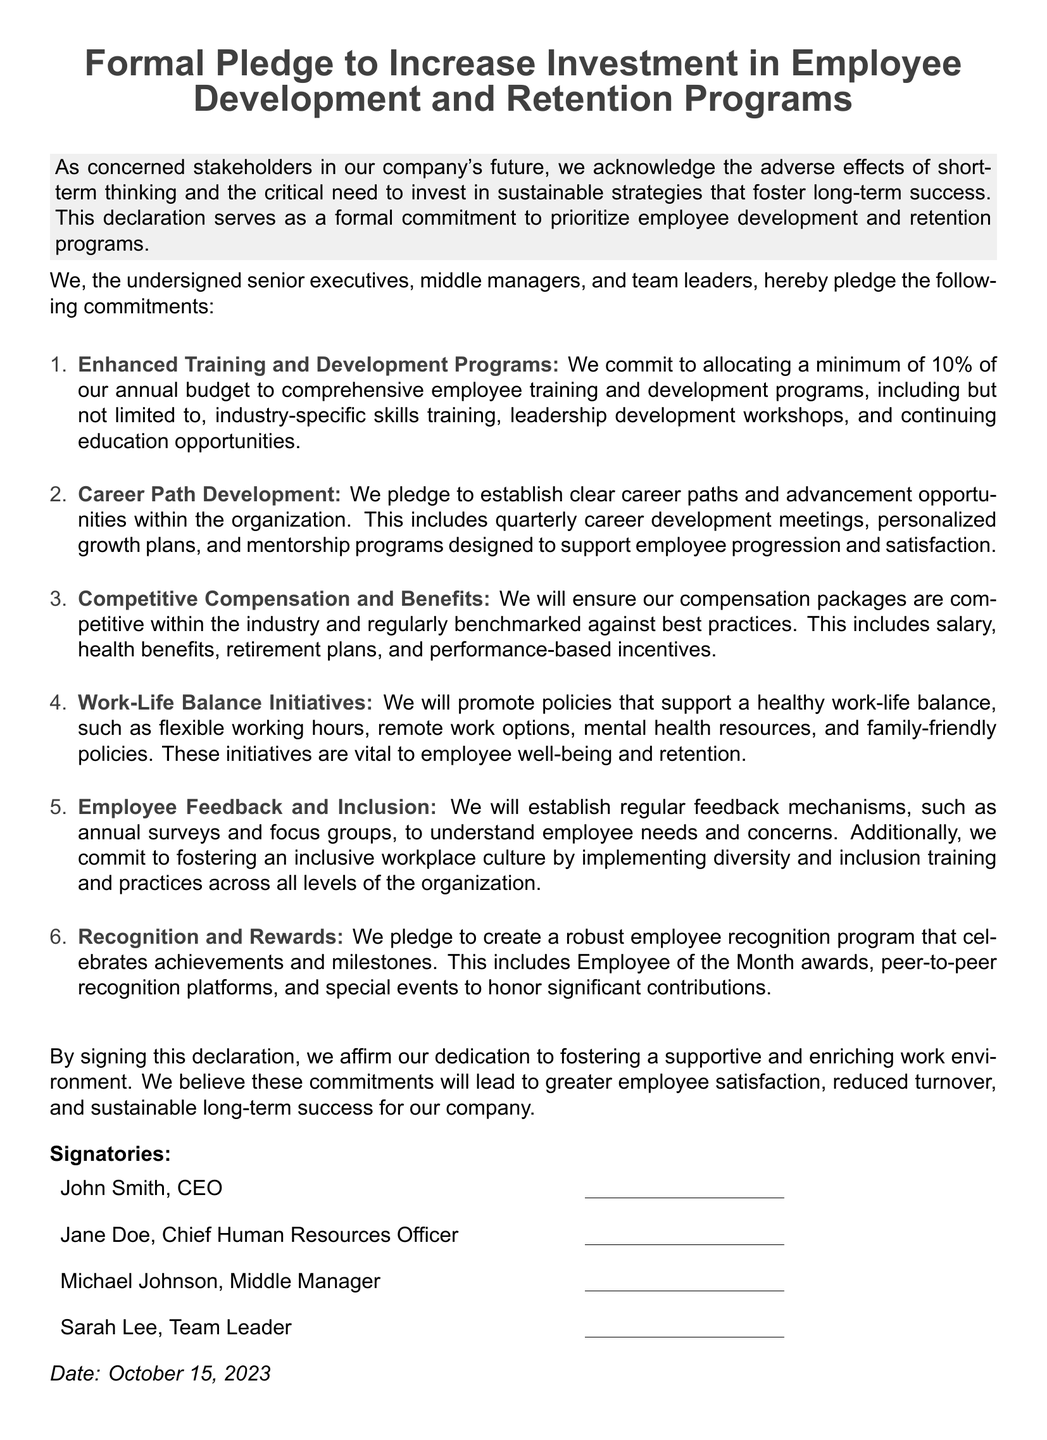What is the title of the document? The title is stated at the beginning of the document, highlighting its primary focus.
Answer: Formal Pledge to Increase Investment in Employee Development and Retention Programs What percentage of the annual budget is committed to training programs? The document specifies a minimum percentage dedicated to employee training and development.
Answer: 10% Who is the Chief Human Resources Officer? The document lists the names and titles of signatories, including the Chief Human Resources Officer.
Answer: Jane Doe What type of programs are included in the training commitment? The document mentions specific types of training encompassed in the commitment.
Answer: Industry-specific skills training, leadership development workshops, and continuing education opportunities What is the purpose of establishing regular feedback mechanisms? The document states the goal behind implementing feedback mechanisms in the organization.
Answer: To understand employee needs and concerns How will competitive compensation be ensured? The document indicates a strategy for maintaining competitive compensation and benefits.
Answer: Regularly benchmarked against best practices What date is specified at the end of the document? The document concludes with a specific date for the declaration.
Answer: October 15, 2023 What is the aim of promoting work-life balance initiatives? The document outlines the importance of certain policies for employees.
Answer: Employee well-being and retention How many commitments are outlined in the document? The document lists a specific number of commitments made by the signatories.
Answer: Six 